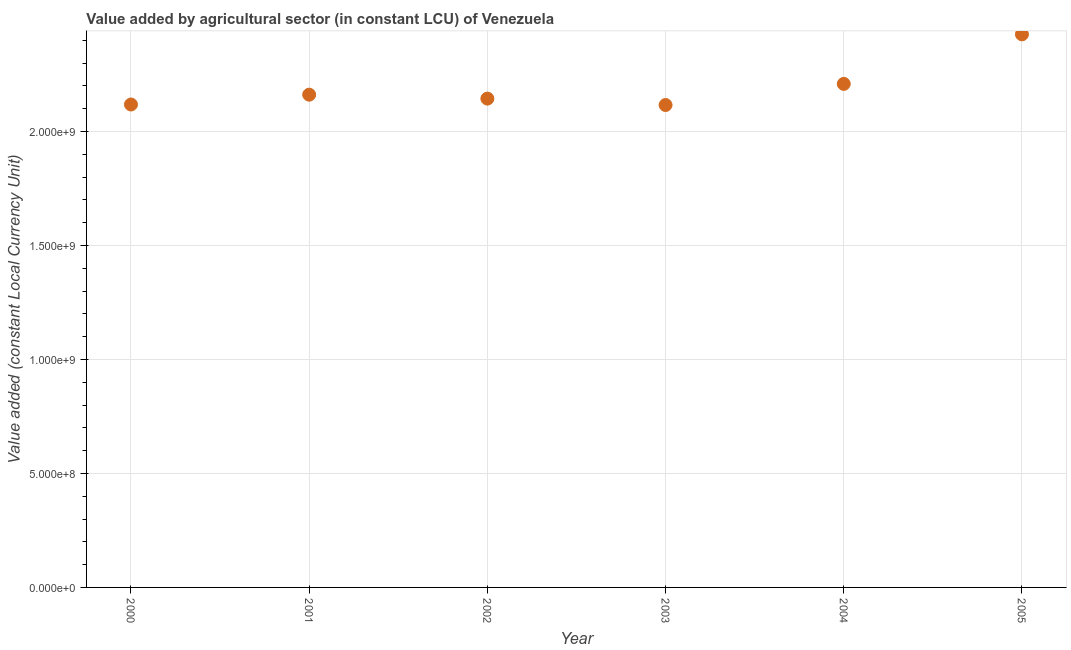What is the value added by agriculture sector in 2001?
Your response must be concise. 2.16e+09. Across all years, what is the maximum value added by agriculture sector?
Offer a very short reply. 2.43e+09. Across all years, what is the minimum value added by agriculture sector?
Your answer should be very brief. 2.12e+09. In which year was the value added by agriculture sector maximum?
Give a very brief answer. 2005. What is the sum of the value added by agriculture sector?
Your answer should be compact. 1.32e+1. What is the difference between the value added by agriculture sector in 2001 and 2005?
Keep it short and to the point. -2.65e+08. What is the average value added by agriculture sector per year?
Your answer should be very brief. 2.20e+09. What is the median value added by agriculture sector?
Your response must be concise. 2.15e+09. Do a majority of the years between 2000 and 2003 (inclusive) have value added by agriculture sector greater than 900000000 LCU?
Your response must be concise. Yes. What is the ratio of the value added by agriculture sector in 2001 to that in 2003?
Your response must be concise. 1.02. Is the difference between the value added by agriculture sector in 2000 and 2005 greater than the difference between any two years?
Make the answer very short. No. What is the difference between the highest and the second highest value added by agriculture sector?
Offer a very short reply. 2.17e+08. Is the sum of the value added by agriculture sector in 2003 and 2004 greater than the maximum value added by agriculture sector across all years?
Your response must be concise. Yes. What is the difference between the highest and the lowest value added by agriculture sector?
Your answer should be very brief. 3.10e+08. How many years are there in the graph?
Ensure brevity in your answer.  6. Are the values on the major ticks of Y-axis written in scientific E-notation?
Your answer should be compact. Yes. What is the title of the graph?
Your response must be concise. Value added by agricultural sector (in constant LCU) of Venezuela. What is the label or title of the Y-axis?
Ensure brevity in your answer.  Value added (constant Local Currency Unit). What is the Value added (constant Local Currency Unit) in 2000?
Make the answer very short. 2.12e+09. What is the Value added (constant Local Currency Unit) in 2001?
Your answer should be compact. 2.16e+09. What is the Value added (constant Local Currency Unit) in 2002?
Provide a succinct answer. 2.14e+09. What is the Value added (constant Local Currency Unit) in 2003?
Your response must be concise. 2.12e+09. What is the Value added (constant Local Currency Unit) in 2004?
Offer a very short reply. 2.21e+09. What is the Value added (constant Local Currency Unit) in 2005?
Provide a short and direct response. 2.43e+09. What is the difference between the Value added (constant Local Currency Unit) in 2000 and 2001?
Offer a very short reply. -4.31e+07. What is the difference between the Value added (constant Local Currency Unit) in 2000 and 2002?
Your response must be concise. -2.59e+07. What is the difference between the Value added (constant Local Currency Unit) in 2000 and 2003?
Your response must be concise. 2.21e+06. What is the difference between the Value added (constant Local Currency Unit) in 2000 and 2004?
Keep it short and to the point. -9.05e+07. What is the difference between the Value added (constant Local Currency Unit) in 2000 and 2005?
Your answer should be compact. -3.08e+08. What is the difference between the Value added (constant Local Currency Unit) in 2001 and 2002?
Your answer should be very brief. 1.73e+07. What is the difference between the Value added (constant Local Currency Unit) in 2001 and 2003?
Provide a short and direct response. 4.54e+07. What is the difference between the Value added (constant Local Currency Unit) in 2001 and 2004?
Make the answer very short. -4.73e+07. What is the difference between the Value added (constant Local Currency Unit) in 2001 and 2005?
Your response must be concise. -2.65e+08. What is the difference between the Value added (constant Local Currency Unit) in 2002 and 2003?
Your answer should be compact. 2.81e+07. What is the difference between the Value added (constant Local Currency Unit) in 2002 and 2004?
Offer a terse response. -6.46e+07. What is the difference between the Value added (constant Local Currency Unit) in 2002 and 2005?
Your answer should be compact. -2.82e+08. What is the difference between the Value added (constant Local Currency Unit) in 2003 and 2004?
Your answer should be compact. -9.27e+07. What is the difference between the Value added (constant Local Currency Unit) in 2003 and 2005?
Provide a short and direct response. -3.10e+08. What is the difference between the Value added (constant Local Currency Unit) in 2004 and 2005?
Provide a short and direct response. -2.17e+08. What is the ratio of the Value added (constant Local Currency Unit) in 2000 to that in 2005?
Your response must be concise. 0.87. What is the ratio of the Value added (constant Local Currency Unit) in 2001 to that in 2002?
Offer a terse response. 1.01. What is the ratio of the Value added (constant Local Currency Unit) in 2001 to that in 2004?
Ensure brevity in your answer.  0.98. What is the ratio of the Value added (constant Local Currency Unit) in 2001 to that in 2005?
Your response must be concise. 0.89. What is the ratio of the Value added (constant Local Currency Unit) in 2002 to that in 2003?
Provide a succinct answer. 1.01. What is the ratio of the Value added (constant Local Currency Unit) in 2002 to that in 2004?
Your answer should be very brief. 0.97. What is the ratio of the Value added (constant Local Currency Unit) in 2002 to that in 2005?
Your response must be concise. 0.88. What is the ratio of the Value added (constant Local Currency Unit) in 2003 to that in 2004?
Keep it short and to the point. 0.96. What is the ratio of the Value added (constant Local Currency Unit) in 2003 to that in 2005?
Give a very brief answer. 0.87. What is the ratio of the Value added (constant Local Currency Unit) in 2004 to that in 2005?
Provide a short and direct response. 0.91. 